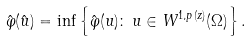<formula> <loc_0><loc_0><loc_500><loc_500>\hat { \varphi } ( \hat { u } ) = \inf \left \{ \hat { \varphi } ( u ) \colon \, u \in W ^ { 1 , p ( z ) } ( \Omega ) \right \} .</formula> 